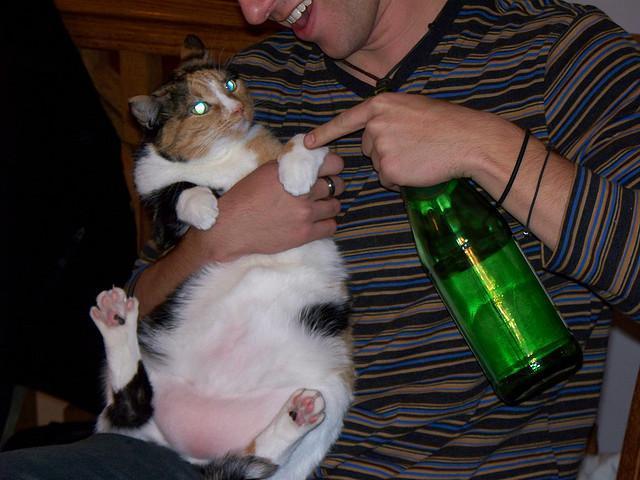How many bottles can you see?
Give a very brief answer. 1. How many people are there?
Give a very brief answer. 2. How many bears are standing near the waterfalls?
Give a very brief answer. 0. 